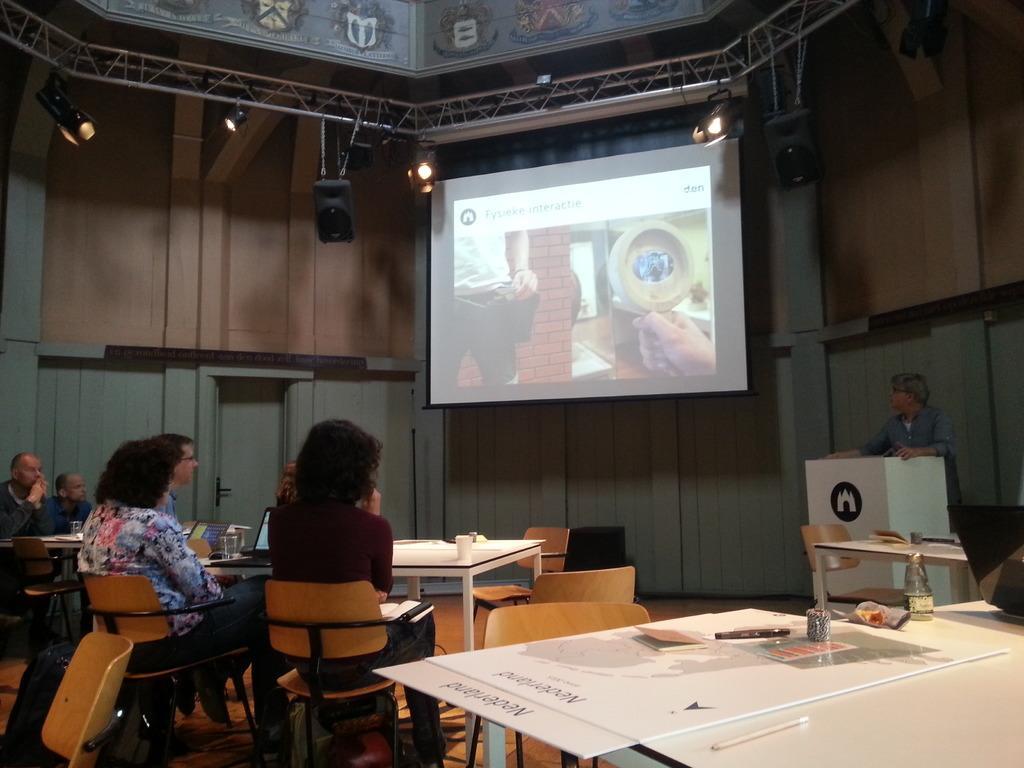Please provide a concise description of this image. Here we can see some persons are sitting on the chairs. These are the tables. On the table there is a bottle, cup, and books. This is a screen and there is a door. Here we can see some lights and this is wall. There is a person who is standing on the floor and this is podium. 